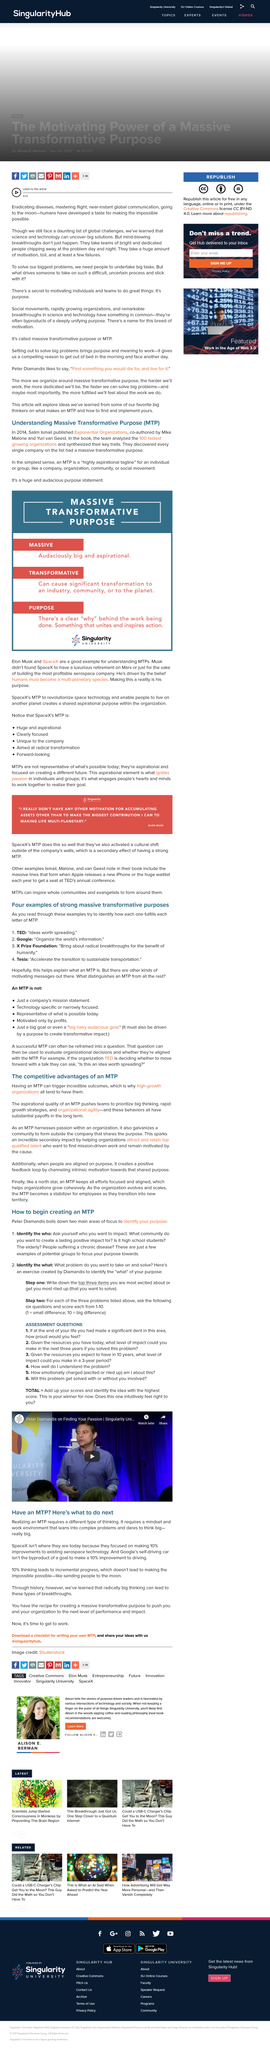Indicate a few pertinent items in this graphic. Through the study of history, we have learned that radical and innovative thinking can result in groundbreaking discoveries and innovations. The title of this section is 'What is the title of this section? Have an MTP? Here's what to do next..'. The person in the thumbnail of the video is possibly Peter Diamandis, as indicated in the title. 